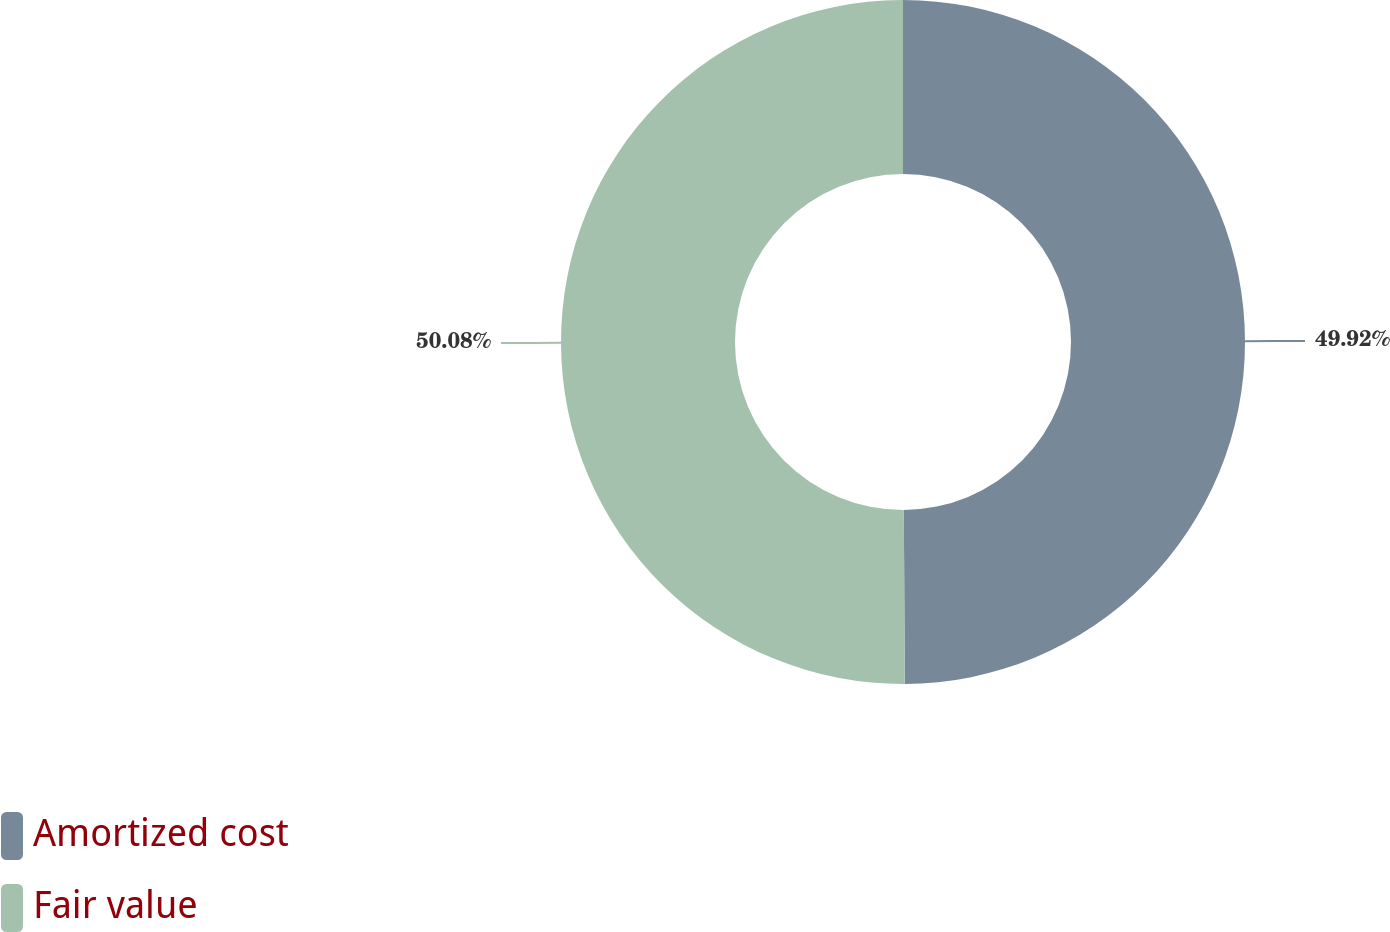Convert chart to OTSL. <chart><loc_0><loc_0><loc_500><loc_500><pie_chart><fcel>Amortized cost<fcel>Fair value<nl><fcel>49.92%<fcel>50.08%<nl></chart> 